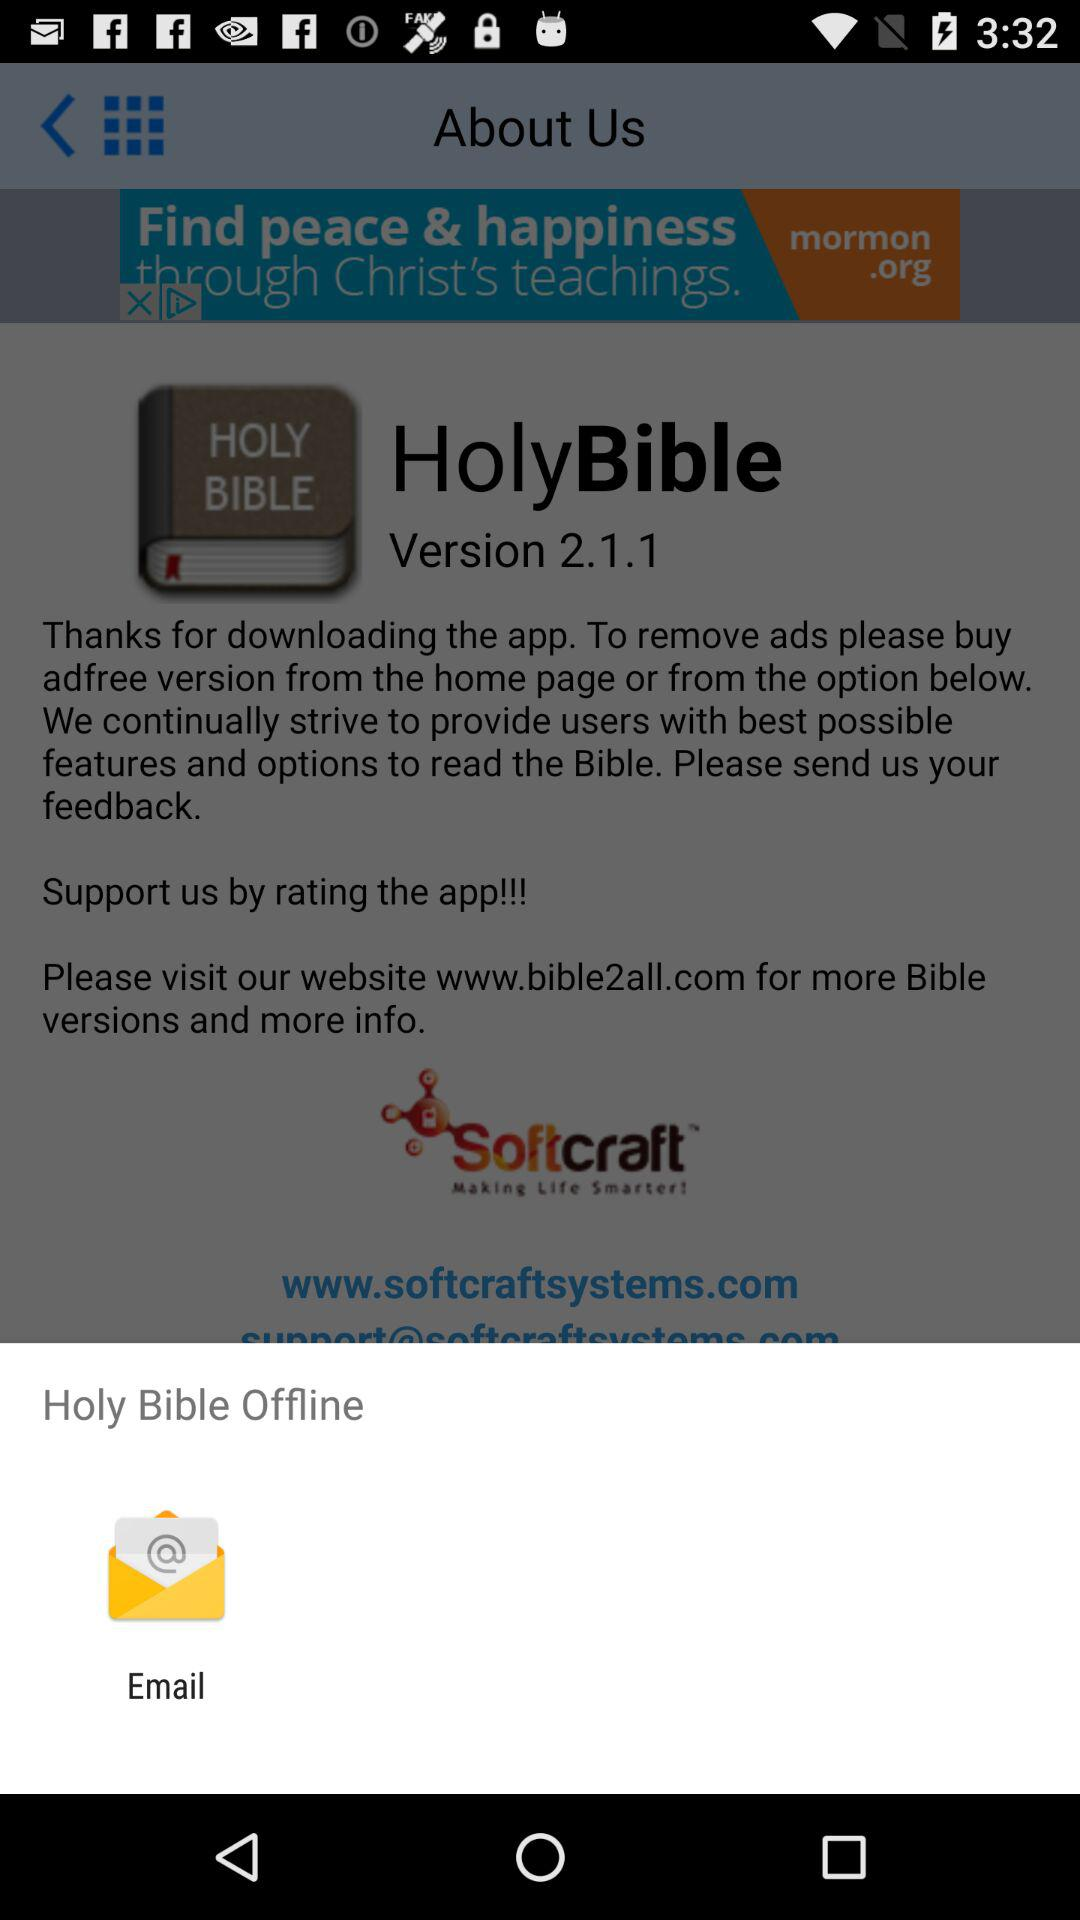What is the version of "HolyBible"? The version of "HolyBible" is 2.1.1. 